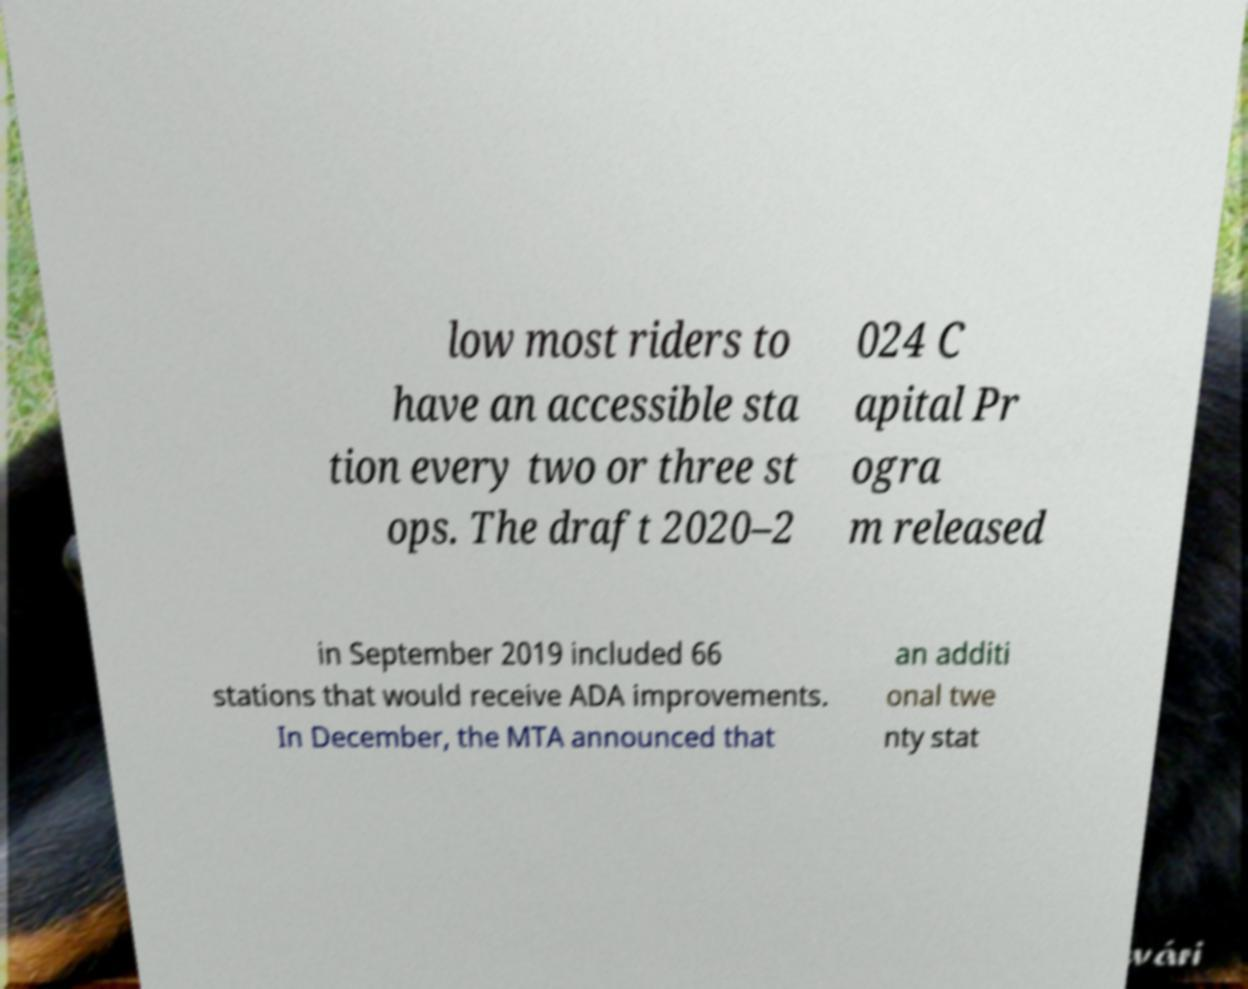Can you accurately transcribe the text from the provided image for me? low most riders to have an accessible sta tion every two or three st ops. The draft 2020–2 024 C apital Pr ogra m released in September 2019 included 66 stations that would receive ADA improvements. In December, the MTA announced that an additi onal twe nty stat 